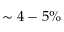Convert formula to latex. <formula><loc_0><loc_0><loc_500><loc_500>\sim 4 - 5 \%</formula> 